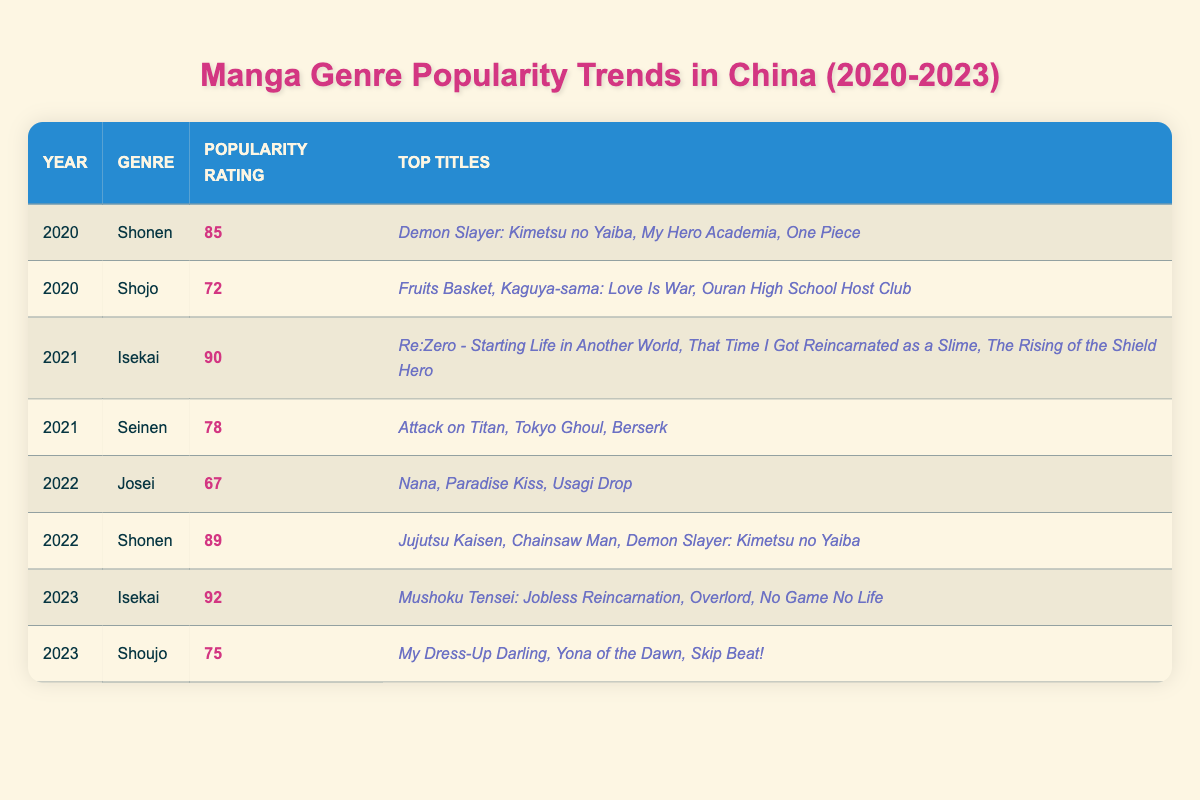What was the popularity rating of Shonen in 2022? In the table, there is a row for the year 2022 and the genre Shonen. The popularity rating listed for Shonen in 2022 is 89.
Answer: 89 Which genre had the highest popularity rating in 2023? The table indicates that in 2023, the genre with the highest popularity rating is Isekai, with a rating of 92.
Answer: Isekai Was there a genre that consistently had a popularity rating above 85 from 2020 to 2023? Looking through the table, Shonen had a popularity rating of 85 in 2020, then increased to 89 in 2022, and does not appear in 2023, while Isekai had ratings of 90 in 2021 and 92 in 2023; however, only Shonen is the only one at or above 85 in three years. Thus, the consistent rating is from 2021 to 2023, and it varies by year.
Answer: No What is the trend in popularity ratings for the Isekai genre from 2021 to 2023? The table shows that in 2021, the Isekai genre had a popularity rating of 90, which increased to 92 in 2023. This indicates an upward trend in popularity over those years.
Answer: Upward trend What is the average popularity rating of Shojo for the years it appears in the table? Shojo appears in two years: 2020 with a rating of 72 and 2023 with a rating of 75. To find the average, we calculate (72 + 75) / 2 = 73.5.
Answer: 73.5 Which year and genre combination had the lowest popularity rating? By scanning the table, the lowest popularity rating is found for the Josei genre in 2022 with a rating of 67.
Answer: 2022, Josei Did Seinen have a higher popularity rating than Shojo in any year? In the table, Seinen has a rating of 78 in 2021 while Shojo's highest rating is 75 in 2023. Therefore, 2021 was the year Seinen was higher than Shojo.
Answer: Yes, in 2021 What were the top three titles for Shonen in 2022? The table provides the top titles listed under the Shonen genre for 2022 as Jujutsu Kaisen, Chainsaw Man, and Demon Slayer: Kimetsu no Yaiba.
Answer: Jujutsu Kaisen, Chainsaw Man, Demon Slayer: Kimetsu no Yaiba 